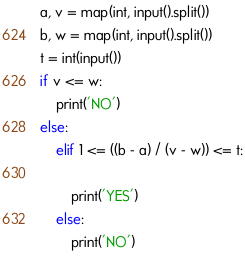<code> <loc_0><loc_0><loc_500><loc_500><_Python_>a, v = map(int, input().split())
b, w = map(int, input().split())
t = int(input())
if v <= w:
    print('NO')
else:
    elif 1 <= ((b - a) / (v - w)) <= t:

        print('YES')
    else:
        print('NO')</code> 